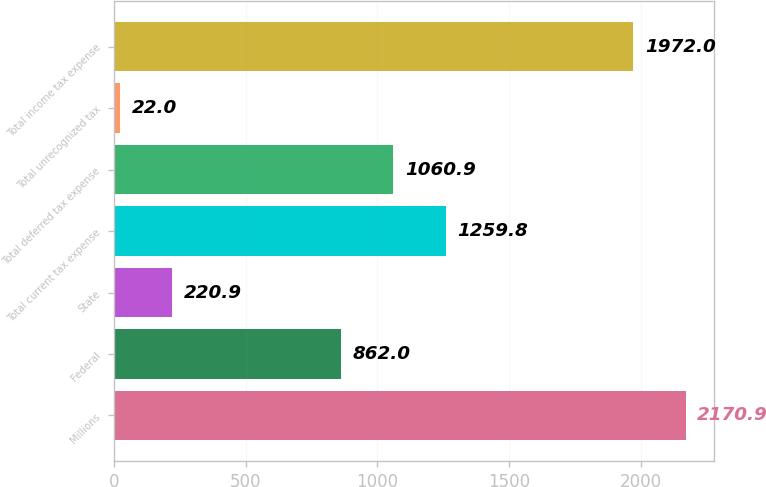<chart> <loc_0><loc_0><loc_500><loc_500><bar_chart><fcel>Millions<fcel>Federal<fcel>State<fcel>Total current tax expense<fcel>Total deferred tax expense<fcel>Total unrecognized tax<fcel>Total income tax expense<nl><fcel>2170.9<fcel>862<fcel>220.9<fcel>1259.8<fcel>1060.9<fcel>22<fcel>1972<nl></chart> 